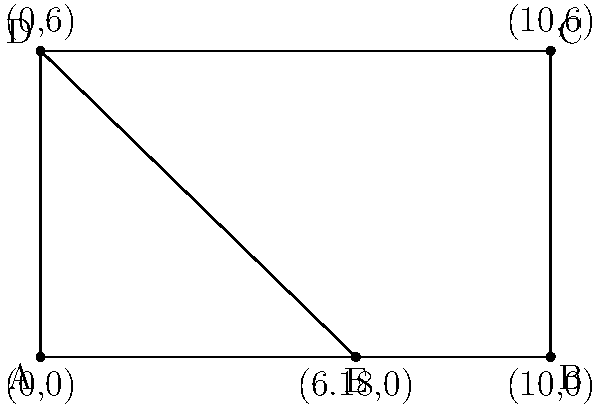In the design of a luxury sedan's side profile, the golden ratio is applied to create an aesthetically pleasing proportion. If the total length of the car (AB) is 5 meters, and point E divides the length according to the golden ratio, what is the length of AE in meters, rounded to two decimal places? To solve this problem, we'll follow these steps:

1) The golden ratio is approximately 1.618034, often denoted by the Greek letter φ (phi).

2) In the golden ratio, the ratio of the whole to the larger part is equal to the ratio of the larger part to the smaller part.

3) If we denote the length of AE as x, then:
   $\frac{AB}{AE} = \frac{AE}{EB}$

4) We know that $AB = 5$ meters and $AB = AE + EB$

5) Using the properties of the golden ratio:
   $\frac{5}{x} = \frac{x}{5-x}$

6) Cross multiply:
   $5(5-x) = x^2$

7) Expand:
   $25 - 5x = x^2$

8) Rearrange:
   $x^2 + 5x - 25 = 0$

9) This is a quadratic equation. We can solve it using the quadratic formula:
   $x = \frac{-b \pm \sqrt{b^2 - 4ac}}{2a}$

   Where $a=1$, $b=5$, and $c=-25$

10) Plugging in these values:
    $x = \frac{-5 \pm \sqrt{25 + 100}}{2} = \frac{-5 \pm \sqrt{125}}{2}$

11) Simplify:
    $x = \frac{-5 \pm 5\sqrt{5}}{2}$

12) We take the positive solution:
    $x = \frac{-5 + 5\sqrt{5}}{2}$

13) Calculate and round to two decimal places:
    $x \approx 3.09$ meters
Answer: 3.09 meters 